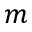<formula> <loc_0><loc_0><loc_500><loc_500>m</formula> 